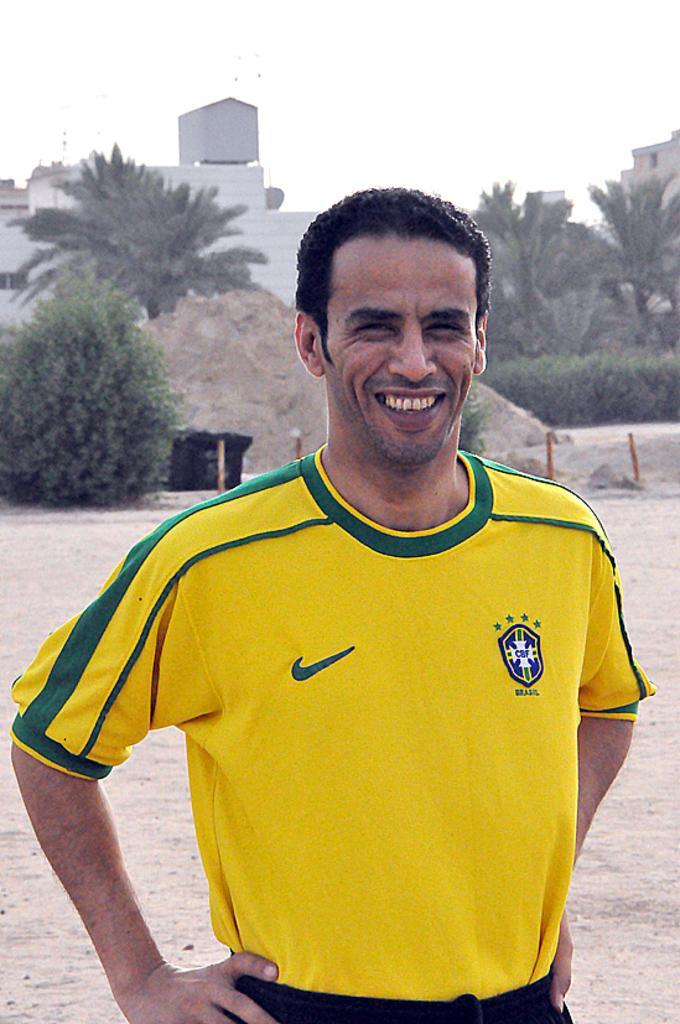Describe this image in one or two sentences. In this image I can see a man wearing yellow color t-shirt, standing and smiling by giving pose to the picture. In the background I can see a building and the trees. On the top of the image I can see the sky. 